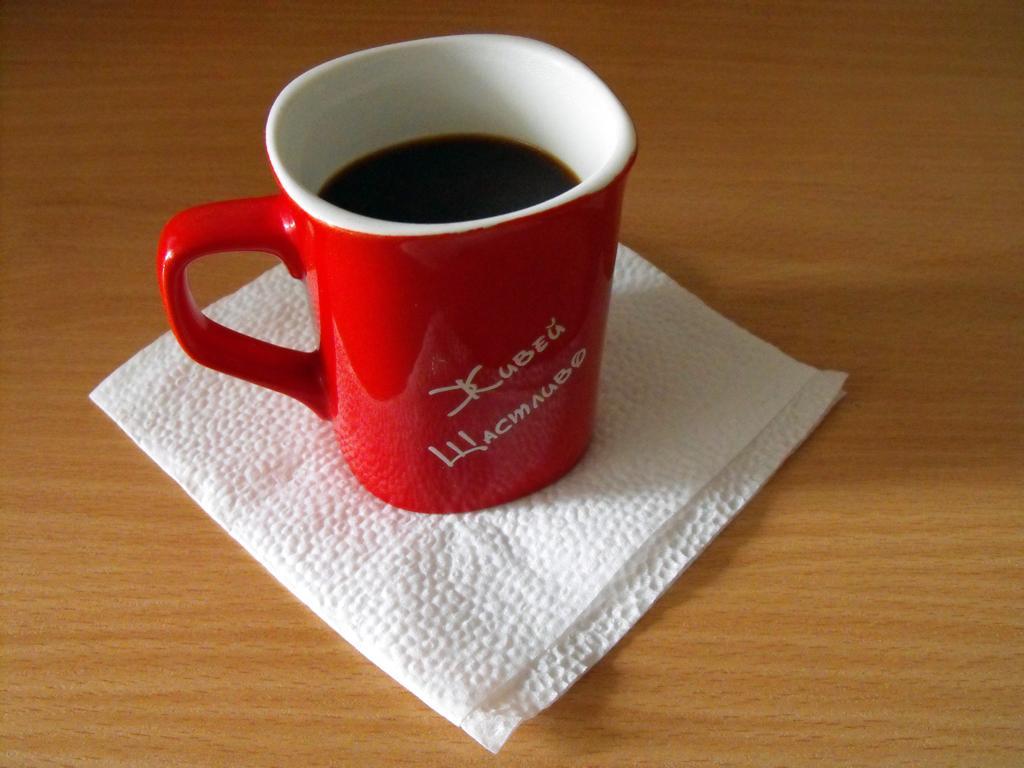How would you summarize this image in a sentence or two? In this image, we can see a table, on the table, we can see a tissue and a cup with some drink. 